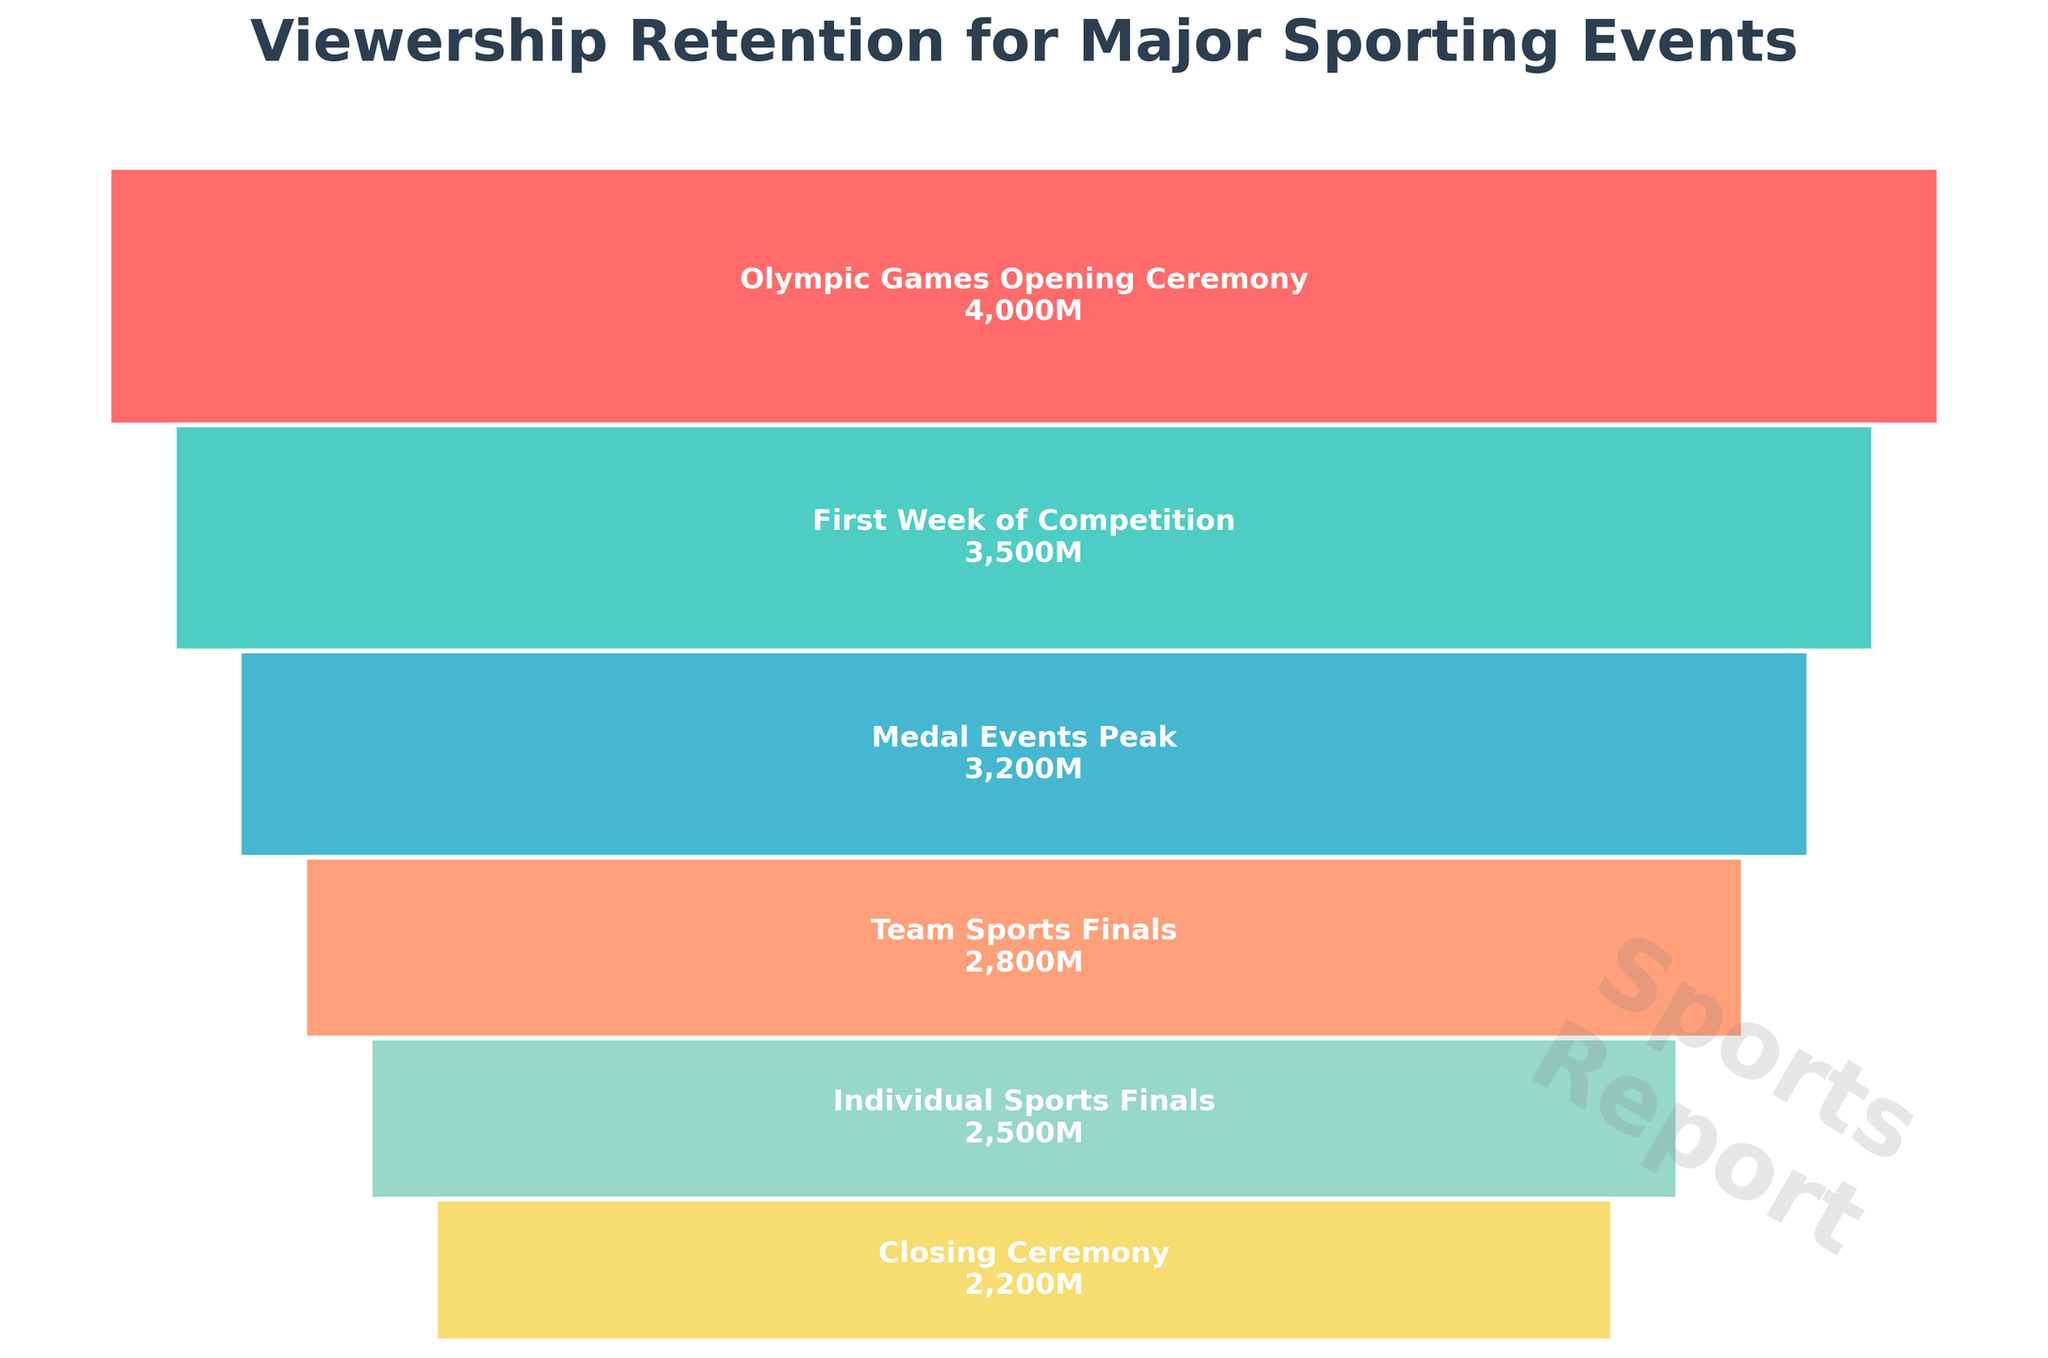Which event attracts the highest number of viewers? The first bar, corresponding to the 'Olympic Games Opening Ceremony', is the tallest, signifying the highest number of viewers.
Answer: Olympic Games Opening Ceremony How many viewers watch the Team Sports Finals? The fourth bar from the top represents the 'Team Sports Finals' and is labeled with 2800 million viewers.
Answer: 2800 million What is the total number of viewers for all events combined? Sum all the viewers for each event: 4000 + 3500 + 3200 + 2800 + 2500 + 2200 = 18,200 million.
Answer: 18,200 million Which event has fewer viewers, the Closing Ceremony or the First Week of Competition? Compare the number of viewers for 'Closing Ceremony' (2200 million) and 'First Week of Competition' (3500 million).
Answer: Closing Ceremony What is the difference in viewership between the Olympic Games Opening Ceremony and the Medal Events Peak? The number of viewers for the 'Olympic Games Opening Ceremony' is 4000 million and for the 'Medal Events Peak' is 3200 million. Difference: 4000 - 3200 = 800 million.
Answer: 800 million Which two events have the closest number of viewers? Compare the viewer numbers: 'Medal Events Peak' (3200 million) and 'Team Sports Finals' (2800 million) have the closest numbers with a difference of 3200 - 2800 = 400 million.
Answer: Medal Events Peak and Team Sports Finals How much does the viewership drop from the Opening Ceremony to the Closing Ceremony? Subtract the number of viewers for the 'Closing Ceremony' from the 'Olympic Games Opening Ceremony' viewers: 4000 - 2200 = 1800 million.
Answer: 1800 million Which event sees the biggest drop in viewership compared to the previous event? Calculate the drops: 
1. 4000-3500 = 500
2. 3500-3200 = 300
3. 3200-2800 = 400
4. 2800-2500 = 300
5. 2500-2200 = 300
The biggest drop is between the 'Olympic Games Opening Ceremony' and the 'First Week of Competition'.
Answer: Olympic Games Opening Ceremony to First Week of Competition 